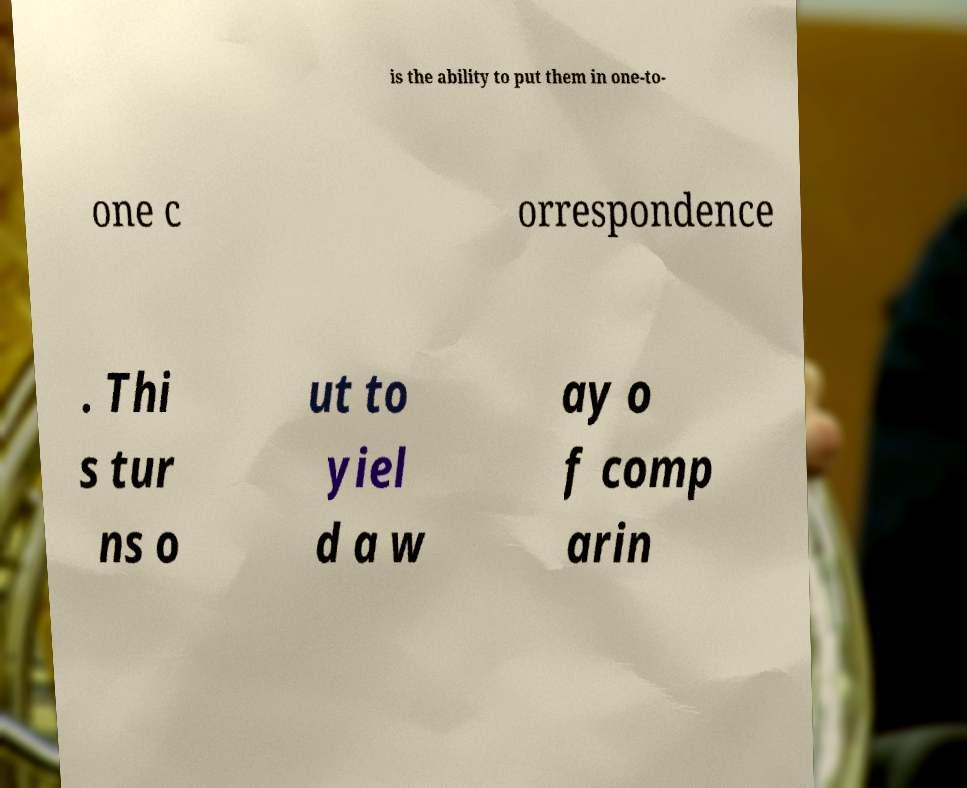Please identify and transcribe the text found in this image. is the ability to put them in one-to- one c orrespondence . Thi s tur ns o ut to yiel d a w ay o f comp arin 